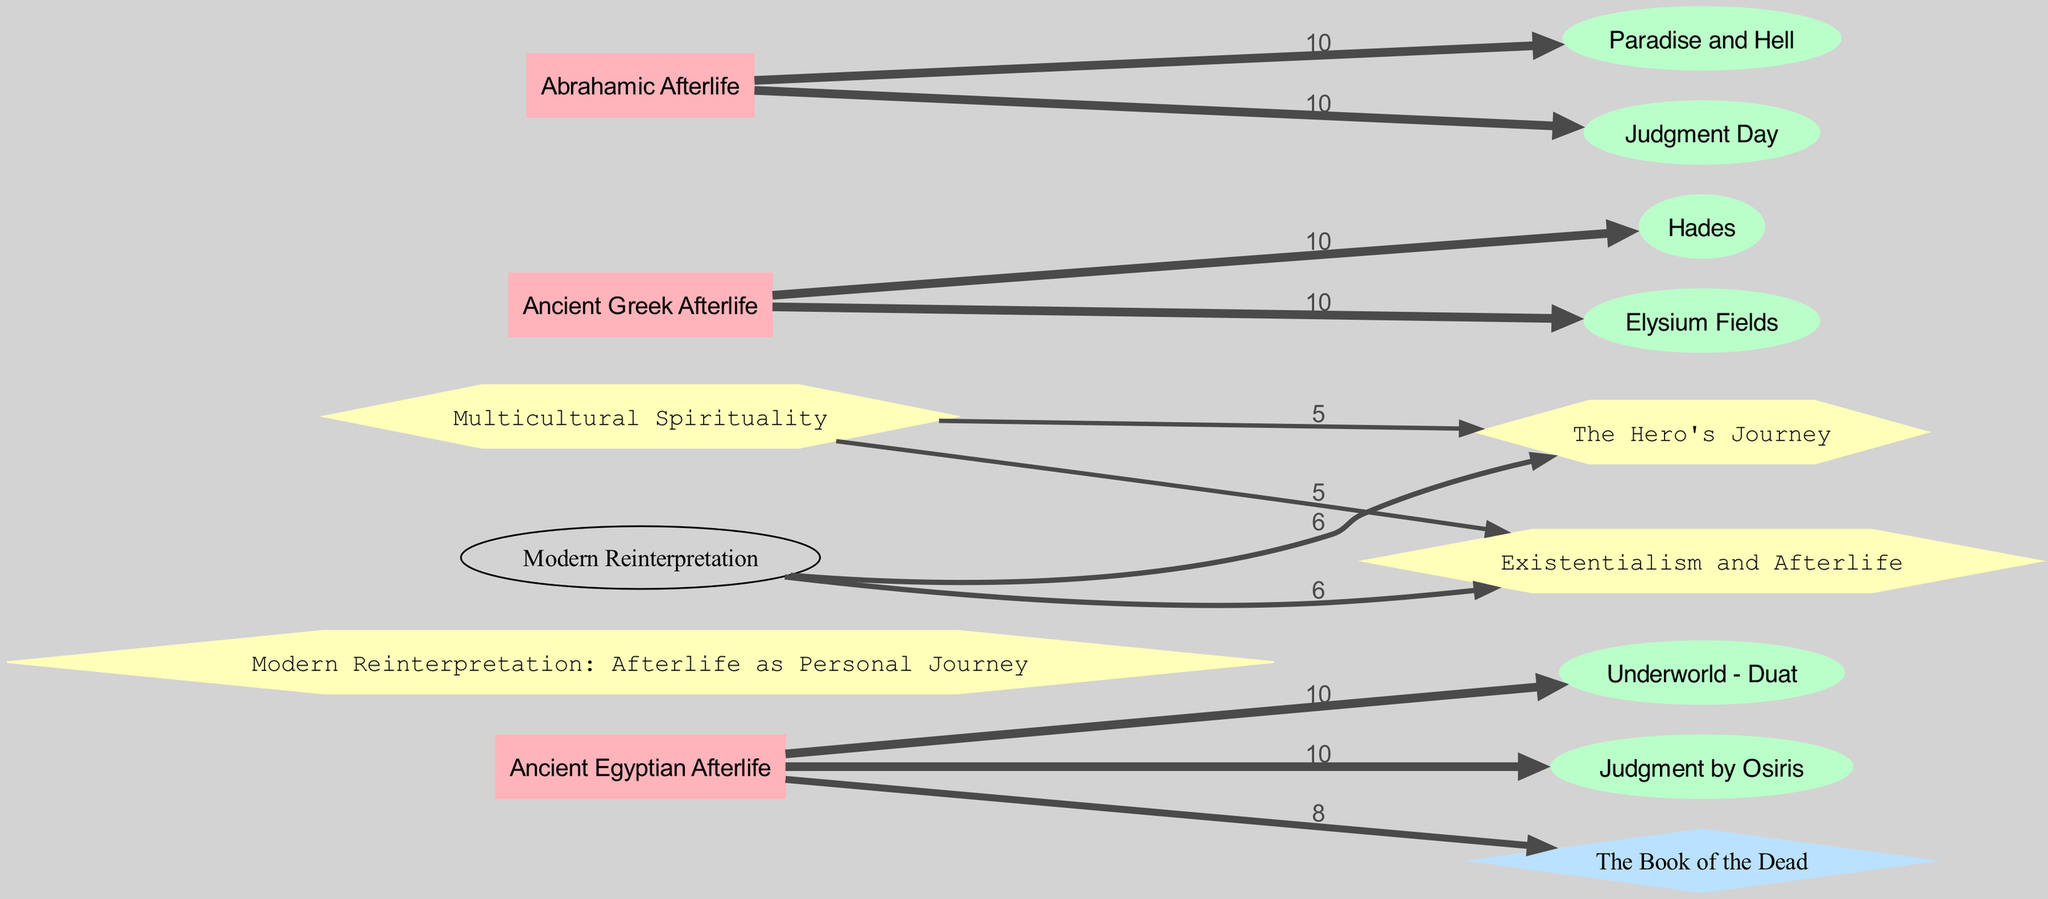What is the value associated with the link between the Ancient Egyptian Afterlife and Judgment by Osiris? The diagram shows a link between "Ancient Egyptian Afterlife" and "Judgment by Osiris" with a value of 10. This indicates the strength or significance of this relationship.
Answer: 10 How many nodes are represented for Ancient Greek Afterlife? In the diagram, there are 3 links extending from "Ancient Greek Afterlife" to "Hades" and "Elysium Fields." Therefore, this indicates that there are two significant concepts related to the Ancient Greek view of the afterlife in the diagram's representation.
Answer: 2 What is the symbol linked to the Abrahamic Afterlife? The Abrahamic Afterlife is linked to two symbols: "Paradise and Hell" and "Judgment Day." The presence of these two links highlights its representation of duality in the afterlife concept within Abrahamic traditions.
Answer: Paradise and Hell, Judgment Day Which modern concept is connected to the Ancient Egyptian Afterlife? The modern concept "Modern Reinterpretation: Afterlife as Personal Journey" connects to elements from the Ancient Egyptian Afterlife. This signifies how ancient beliefs are reshaped and reinterpreted in contemporary views, showing continuity and evolution in understanding afterlife.
Answer: Afterlife as Personal Journey How does the value of connections differ for Multicultural Spirituality? Multicultural Spirituality has links to the "The Hero's Journey" and "Existentialism and Afterlife," both with values of 5. This lower value compared to other connections signifies a less emphasized interpretation of these modern concepts in relation to Multicultural Spirituality compared to others in the diagram.
Answer: 5 